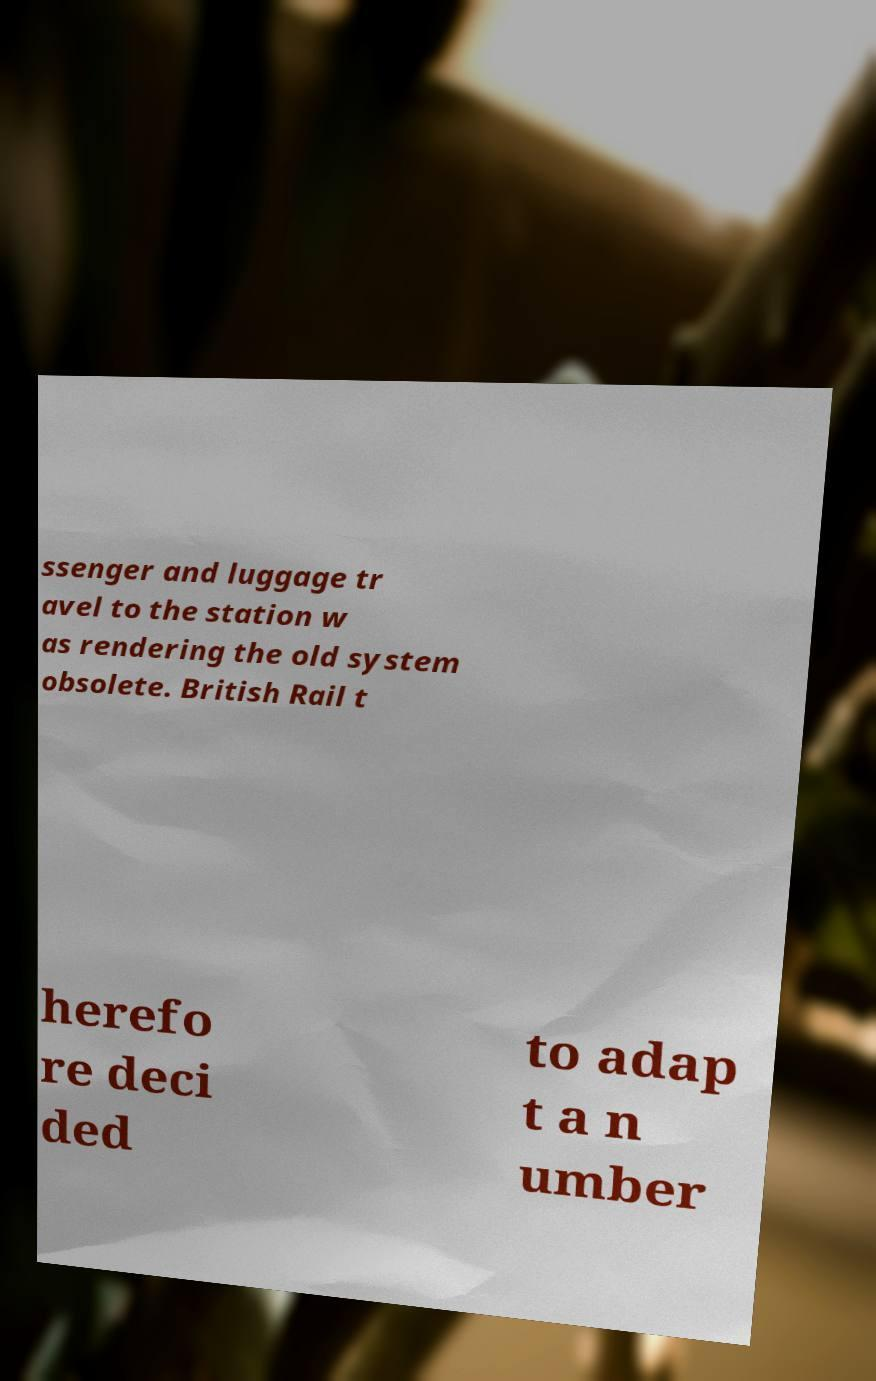Could you assist in decoding the text presented in this image and type it out clearly? ssenger and luggage tr avel to the station w as rendering the old system obsolete. British Rail t herefo re deci ded to adap t a n umber 